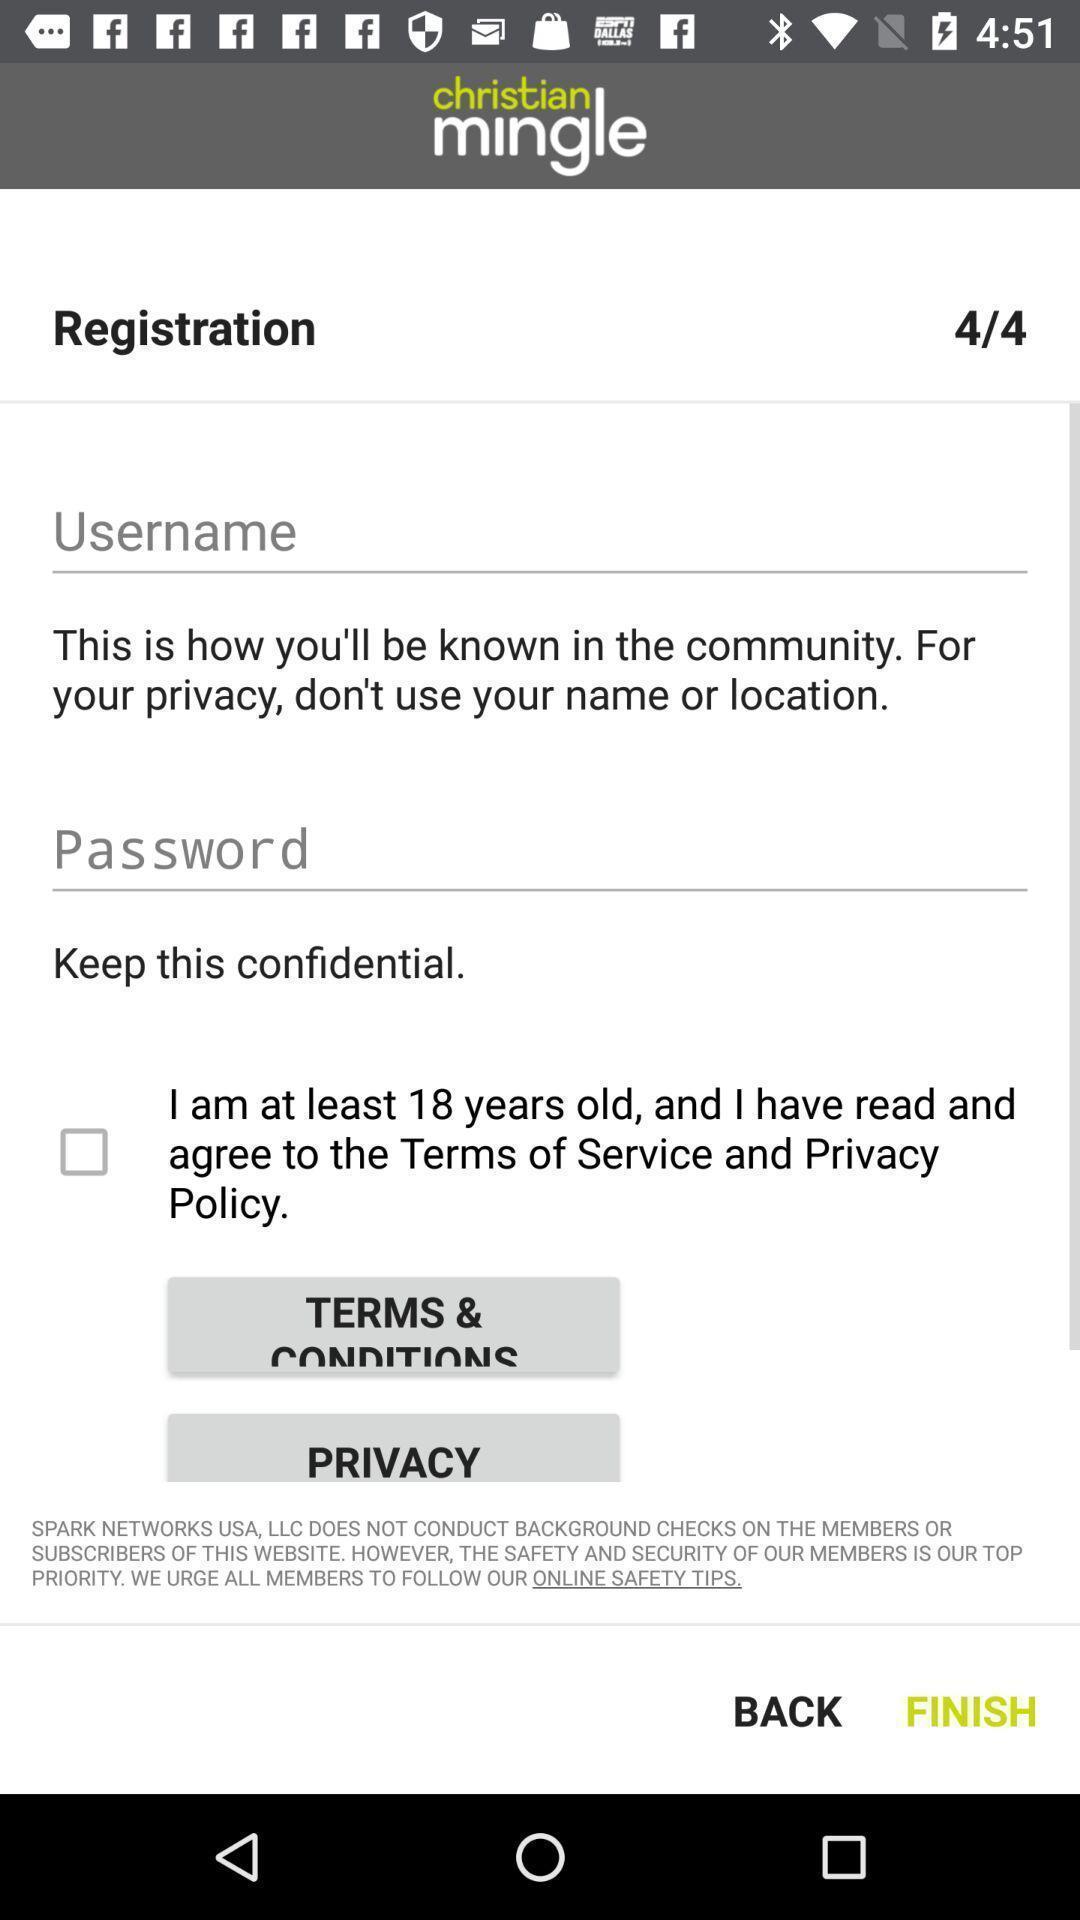Describe this image in words. Welcome to the sign in page. 